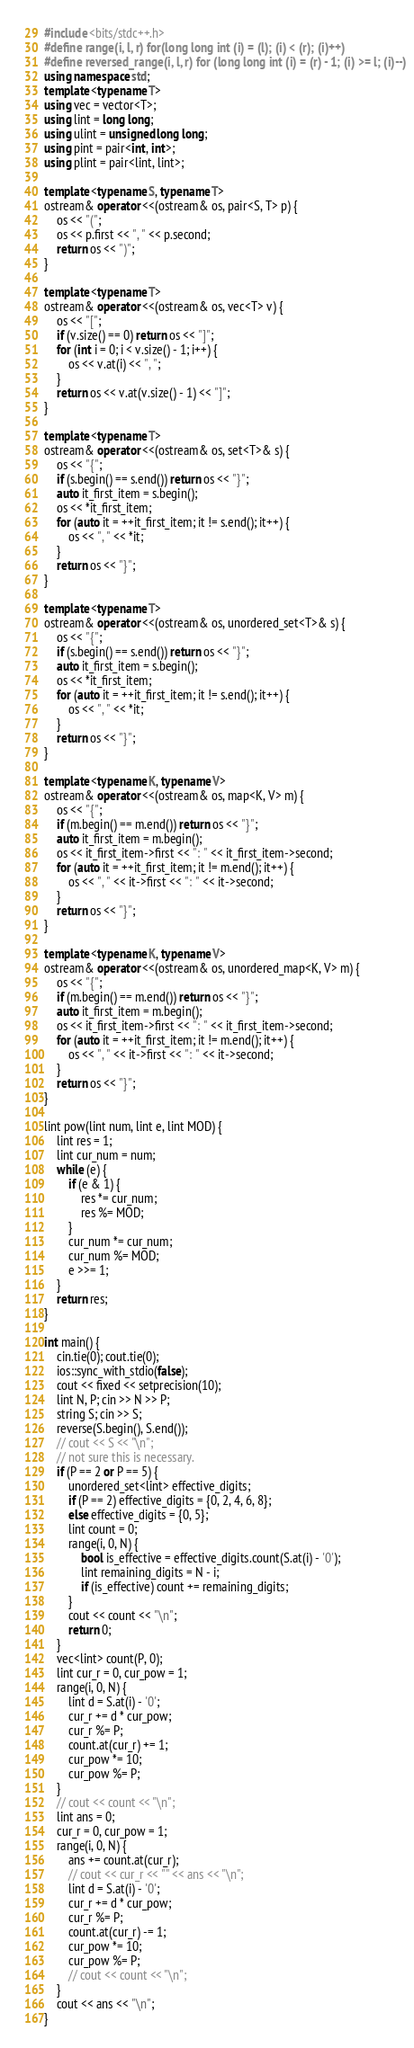<code> <loc_0><loc_0><loc_500><loc_500><_C++_>#include <bits/stdc++.h>
#define range(i, l, r) for(long long int (i) = (l); (i) < (r); (i)++)
#define reversed_range(i, l, r) for (long long int (i) = (r) - 1; (i) >= l; (i)--)
using namespace std;
template <typename T>
using vec = vector<T>;
using lint = long long;
using ulint = unsigned long long;
using pint = pair<int, int>;
using plint = pair<lint, lint>;

template <typename S, typename T>
ostream& operator <<(ostream& os, pair<S, T> p) {
    os << "(";
    os << p.first << ", " << p.second;
    return os << ")";
}

template <typename T>
ostream& operator <<(ostream& os, vec<T> v) {
    os << "[";
    if (v.size() == 0) return os << "]";
    for (int i = 0; i < v.size() - 1; i++) {
        os << v.at(i) << ", ";
    }
    return os << v.at(v.size() - 1) << "]";
}

template <typename T>
ostream& operator <<(ostream& os, set<T>& s) {
    os << "{";
    if (s.begin() == s.end()) return os << "}";
    auto it_first_item = s.begin();
    os << *it_first_item;
    for (auto it = ++it_first_item; it != s.end(); it++) {
        os << ", " << *it;
    }
    return os << "}";
}

template <typename T>
ostream& operator <<(ostream& os, unordered_set<T>& s) {
    os << "{";
    if (s.begin() == s.end()) return os << "}";
    auto it_first_item = s.begin();
    os << *it_first_item;
    for (auto it = ++it_first_item; it != s.end(); it++) {
        os << ", " << *it;
    }
    return os << "}";
}

template <typename K, typename V>
ostream& operator <<(ostream& os, map<K, V> m) {
    os << "{";
    if (m.begin() == m.end()) return os << "}";
    auto it_first_item = m.begin();
    os << it_first_item->first << ": " << it_first_item->second;
    for (auto it = ++it_first_item; it != m.end(); it++) {
        os << ", " << it->first << ": " << it->second;
    }
    return os << "}";
}

template <typename K, typename V>
ostream& operator <<(ostream& os, unordered_map<K, V> m) {
    os << "{";
    if (m.begin() == m.end()) return os << "}";
    auto it_first_item = m.begin();
    os << it_first_item->first << ": " << it_first_item->second;
    for (auto it = ++it_first_item; it != m.end(); it++) {
        os << ", " << it->first << ": " << it->second;
    }
    return os << "}";
}

lint pow(lint num, lint e, lint MOD) {
    lint res = 1;
    lint cur_num = num;
    while (e) {
        if (e & 1) {
            res *= cur_num;
            res %= MOD;
        }
        cur_num *= cur_num;
        cur_num %= MOD;
        e >>= 1;
    }
    return res;
}

int main() {
    cin.tie(0); cout.tie(0);
    ios::sync_with_stdio(false);
    cout << fixed << setprecision(10);
    lint N, P; cin >> N >> P;
    string S; cin >> S;
    reverse(S.begin(), S.end());
    // cout << S << "\n";
    // not sure this is necessary.
    if (P == 2 or P == 5) {
        unordered_set<lint> effective_digits;
        if (P == 2) effective_digits = {0, 2, 4, 6, 8};
        else effective_digits = {0, 5};
        lint count = 0;
        range(i, 0, N) {
            bool is_effective = effective_digits.count(S.at(i) - '0');
            lint remaining_digits = N - i;
            if (is_effective) count += remaining_digits;
        }
        cout << count << "\n";
        return 0;
    }
    vec<lint> count(P, 0);
    lint cur_r = 0, cur_pow = 1;
    range(i, 0, N) {
        lint d = S.at(i) - '0';
        cur_r += d * cur_pow;
        cur_r %= P;
        count.at(cur_r) += 1;
        cur_pow *= 10;
        cur_pow %= P;
    }
    // cout << count << "\n";
    lint ans = 0;
    cur_r = 0, cur_pow = 1;
    range(i, 0, N) {
        ans += count.at(cur_r);
        // cout << cur_r << " " << ans << "\n";
        lint d = S.at(i) - '0';
        cur_r += d * cur_pow;
        cur_r %= P;
        count.at(cur_r) -= 1;
        cur_pow *= 10;
        cur_pow %= P;
        // cout << count << "\n";
    }
    cout << ans << "\n";
}</code> 